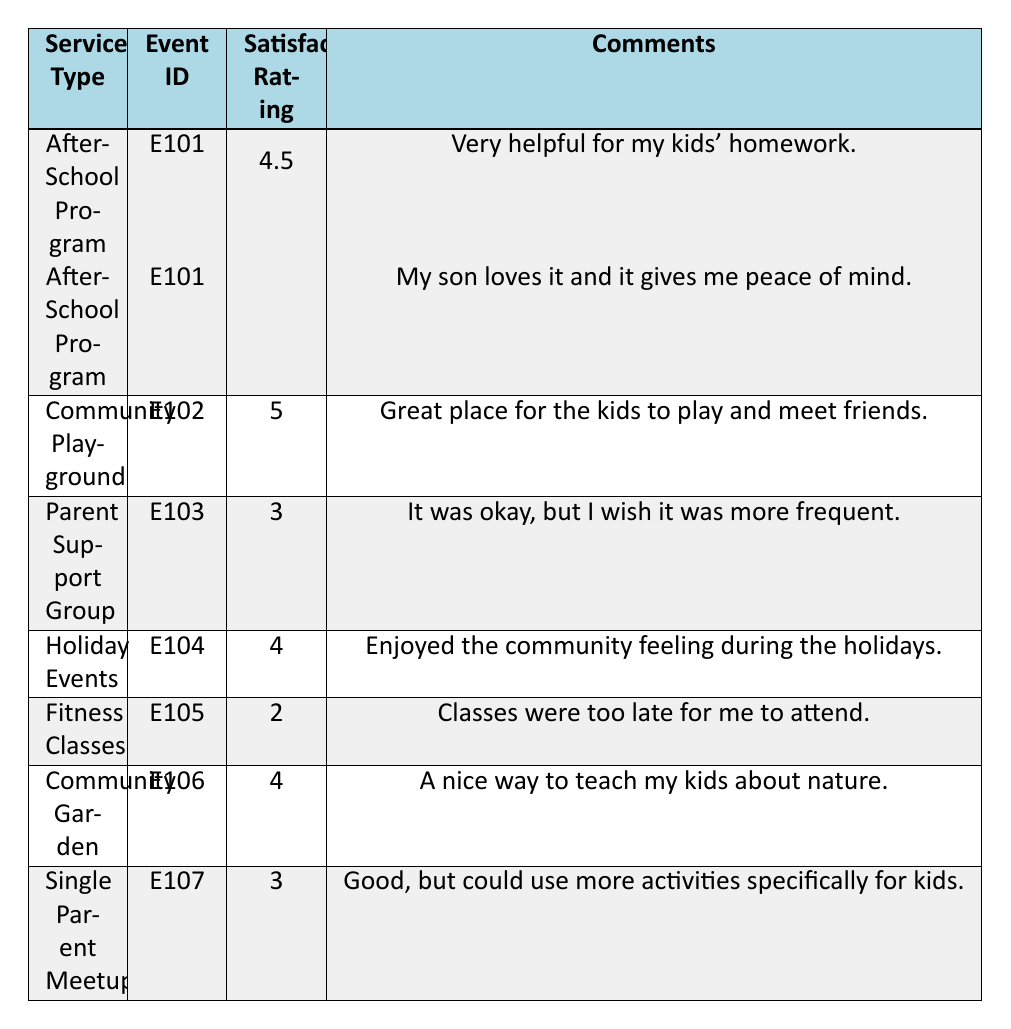What is the satisfaction rating for the Community Playground? The table shows a satisfaction rating of 5 for the Community Playground under event ID E102.
Answer: 5 Which service type has the lowest satisfaction rating? Looking at the table, the Fitness Classes have the lowest satisfaction rating of 2.
Answer: Fitness Classes What is the average satisfaction rating for the After-School Program? The After-School Program has two ratings: 4 and 5. The average is (4 + 5) / 2 = 4.5.
Answer: 4.5 Did any parents express dissatisfaction with the Fitness Classes? The comment for the Fitness Classes indicates dissatisfaction as it states the classes were "too late for me to attend."
Answer: Yes How many service types have a satisfaction rating of 4 or higher? The service types that have ratings of 4 or higher are the After-School Program (4.5), Community Playground (5), Holiday Events (4), and Community Garden (4). This results in 4 service types total.
Answer: 4 What was the general sentiment expressed in the comments for the Holiday Events? The comment under Holiday Events states, "Enjoyed the community feeling during the holidays," which reflects a positive sentiment.
Answer: Positive Is it true that all feedback on the Parent Support Group was highly positive? The comment indicates the feedback was mixed, stating, "It was okay, but I wish it was more frequent," so it is not highly positive.
Answer: No Which event received mixed feedback, and what did it say? The Parent Support Group received mixed feedback. The comment reads, "It was okay, but I wish it was more frequent," indicating a desire for improvement.
Answer: Parent Support Group; "It was okay, but I wish it was more frequent." What is the difference between the highest and lowest satisfaction ratings? The highest rating is 5 (Community Playground), and the lowest is 2 (Fitness Classes). The difference is 5 - 2 = 3.
Answer: 3 If a new event were to be added, what suggestions could be drawn from the comments for improvement? The comments indicate that parents appreciate programs that are timely and engaging for children (e.g., increasing frequency of Parent Support Groups and ensuring scheduling fits parents' needs).
Answer: Increase frequency and better scheduling 